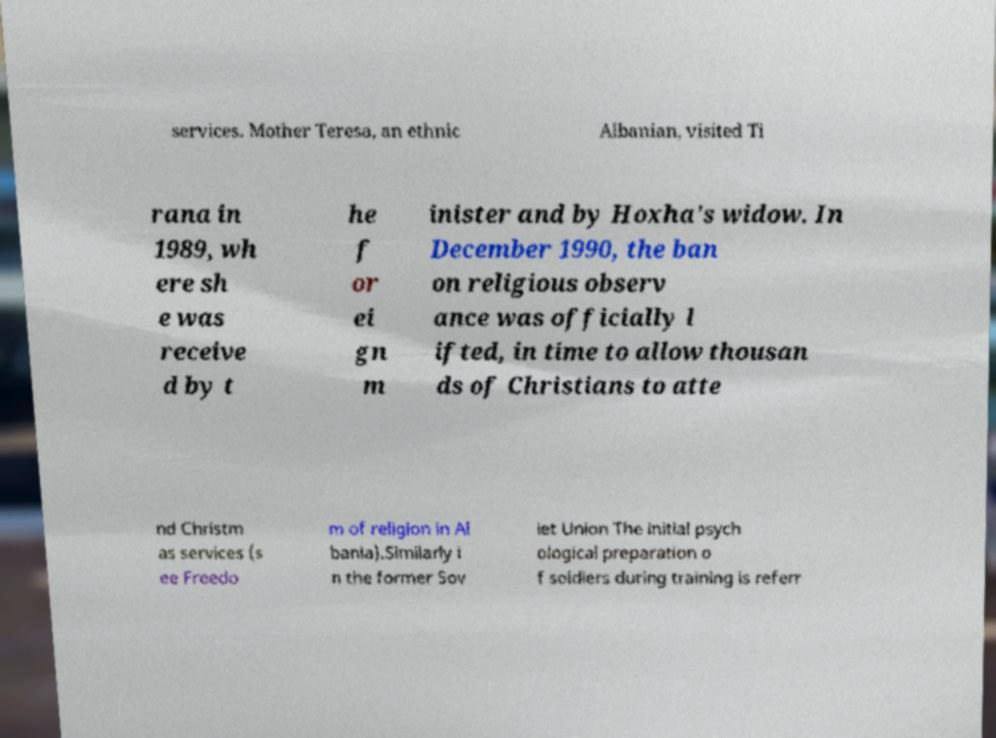I need the written content from this picture converted into text. Can you do that? services. Mother Teresa, an ethnic Albanian, visited Ti rana in 1989, wh ere sh e was receive d by t he f or ei gn m inister and by Hoxha's widow. In December 1990, the ban on religious observ ance was officially l ifted, in time to allow thousan ds of Christians to atte nd Christm as services (s ee Freedo m of religion in Al bania).Similarly i n the former Sov iet Union The initial psych ological preparation o f soldiers during training is referr 